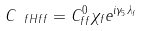Convert formula to latex. <formula><loc_0><loc_0><loc_500><loc_500>C _ { \ f H f f } = C ^ { 0 } _ { f f } \chi _ { f } e ^ { i \gamma _ { 5 } \lambda _ { f } }</formula> 